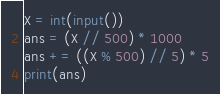<code> <loc_0><loc_0><loc_500><loc_500><_Python_>X = int(input())
ans = (X // 500) * 1000    
ans += ((X % 500) // 5) * 5
print(ans)</code> 